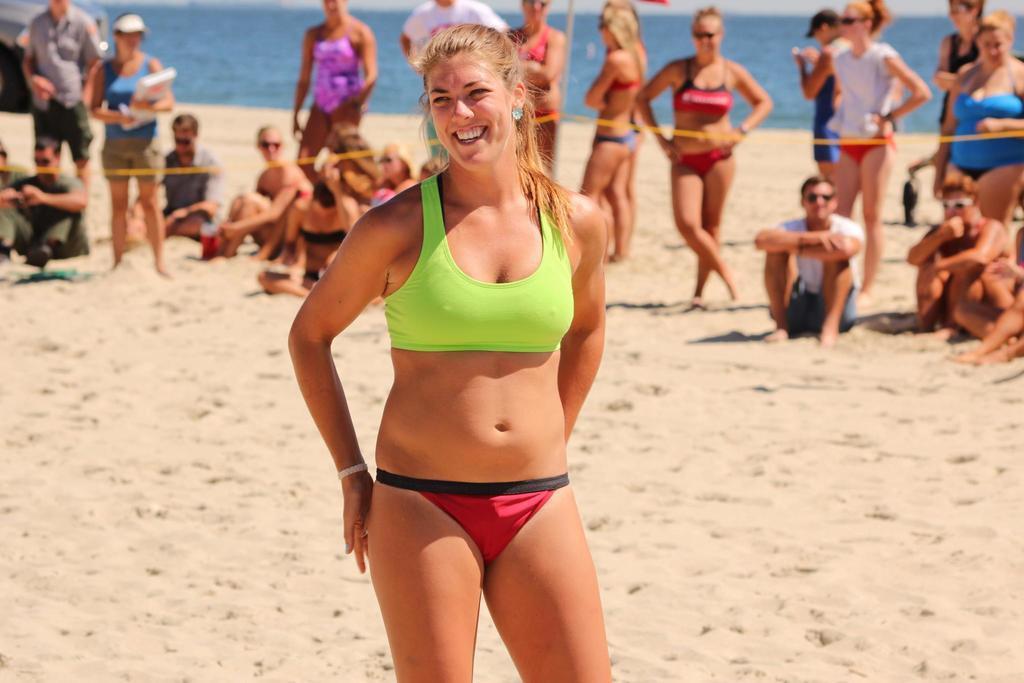Please provide a concise description of this image. Here a woman is standing, here some people are standing and some people are sitting in the sand, this is water. 